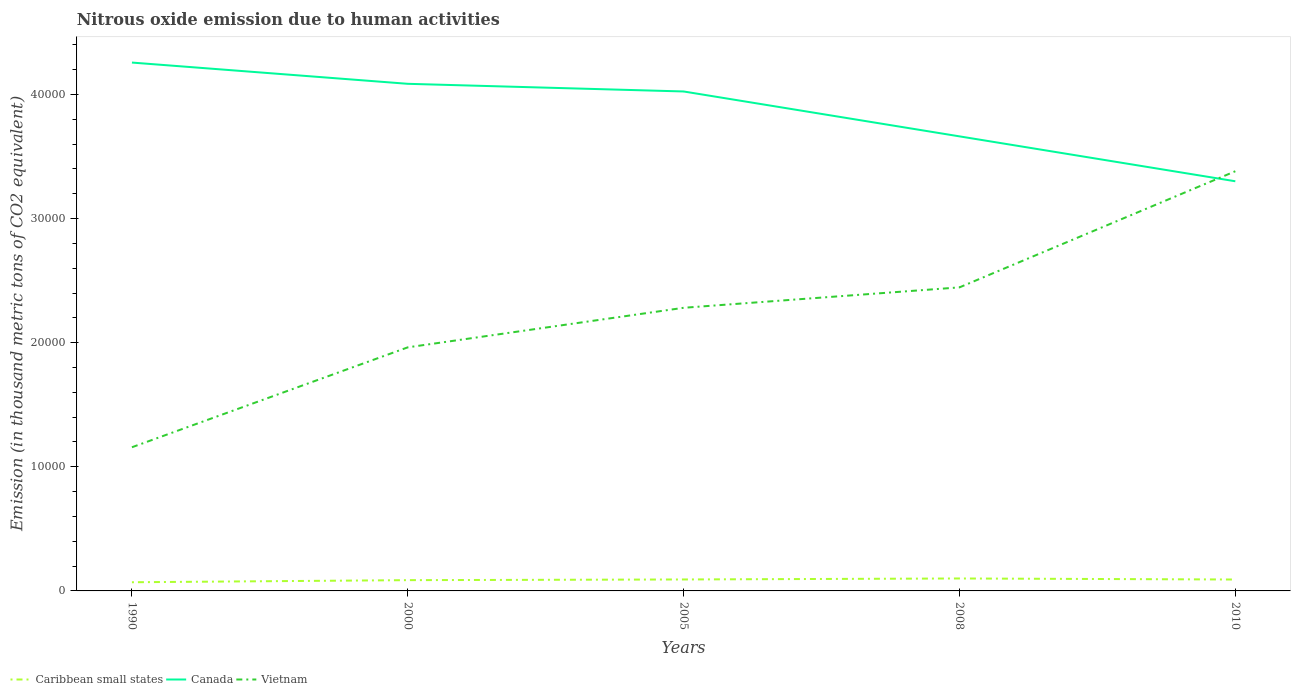Across all years, what is the maximum amount of nitrous oxide emitted in Caribbean small states?
Ensure brevity in your answer.  699.1. What is the total amount of nitrous oxide emitted in Caribbean small states in the graph?
Ensure brevity in your answer.  -135.7. What is the difference between the highest and the second highest amount of nitrous oxide emitted in Canada?
Make the answer very short. 9564.7. What is the difference between the highest and the lowest amount of nitrous oxide emitted in Vietnam?
Make the answer very short. 3. Is the amount of nitrous oxide emitted in Canada strictly greater than the amount of nitrous oxide emitted in Caribbean small states over the years?
Your answer should be compact. No. How many lines are there?
Provide a short and direct response. 3. How many years are there in the graph?
Make the answer very short. 5. What is the difference between two consecutive major ticks on the Y-axis?
Make the answer very short. 10000. How many legend labels are there?
Provide a succinct answer. 3. How are the legend labels stacked?
Give a very brief answer. Horizontal. What is the title of the graph?
Keep it short and to the point. Nitrous oxide emission due to human activities. Does "Malaysia" appear as one of the legend labels in the graph?
Provide a short and direct response. No. What is the label or title of the X-axis?
Your response must be concise. Years. What is the label or title of the Y-axis?
Your answer should be very brief. Emission (in thousand metric tons of CO2 equivalent). What is the Emission (in thousand metric tons of CO2 equivalent) in Caribbean small states in 1990?
Keep it short and to the point. 699.1. What is the Emission (in thousand metric tons of CO2 equivalent) of Canada in 1990?
Ensure brevity in your answer.  4.26e+04. What is the Emission (in thousand metric tons of CO2 equivalent) in Vietnam in 1990?
Make the answer very short. 1.16e+04. What is the Emission (in thousand metric tons of CO2 equivalent) of Caribbean small states in 2000?
Your response must be concise. 867.7. What is the Emission (in thousand metric tons of CO2 equivalent) of Canada in 2000?
Make the answer very short. 4.09e+04. What is the Emission (in thousand metric tons of CO2 equivalent) of Vietnam in 2000?
Provide a short and direct response. 1.96e+04. What is the Emission (in thousand metric tons of CO2 equivalent) of Caribbean small states in 2005?
Offer a terse response. 923.3. What is the Emission (in thousand metric tons of CO2 equivalent) in Canada in 2005?
Offer a terse response. 4.02e+04. What is the Emission (in thousand metric tons of CO2 equivalent) in Vietnam in 2005?
Offer a very short reply. 2.28e+04. What is the Emission (in thousand metric tons of CO2 equivalent) in Caribbean small states in 2008?
Ensure brevity in your answer.  1003.4. What is the Emission (in thousand metric tons of CO2 equivalent) in Canada in 2008?
Offer a very short reply. 3.66e+04. What is the Emission (in thousand metric tons of CO2 equivalent) in Vietnam in 2008?
Offer a terse response. 2.45e+04. What is the Emission (in thousand metric tons of CO2 equivalent) in Caribbean small states in 2010?
Your answer should be very brief. 919.1. What is the Emission (in thousand metric tons of CO2 equivalent) of Canada in 2010?
Offer a very short reply. 3.30e+04. What is the Emission (in thousand metric tons of CO2 equivalent) of Vietnam in 2010?
Offer a terse response. 3.38e+04. Across all years, what is the maximum Emission (in thousand metric tons of CO2 equivalent) in Caribbean small states?
Keep it short and to the point. 1003.4. Across all years, what is the maximum Emission (in thousand metric tons of CO2 equivalent) in Canada?
Provide a short and direct response. 4.26e+04. Across all years, what is the maximum Emission (in thousand metric tons of CO2 equivalent) of Vietnam?
Provide a short and direct response. 3.38e+04. Across all years, what is the minimum Emission (in thousand metric tons of CO2 equivalent) of Caribbean small states?
Provide a short and direct response. 699.1. Across all years, what is the minimum Emission (in thousand metric tons of CO2 equivalent) of Canada?
Keep it short and to the point. 3.30e+04. Across all years, what is the minimum Emission (in thousand metric tons of CO2 equivalent) of Vietnam?
Offer a very short reply. 1.16e+04. What is the total Emission (in thousand metric tons of CO2 equivalent) in Caribbean small states in the graph?
Provide a short and direct response. 4412.6. What is the total Emission (in thousand metric tons of CO2 equivalent) in Canada in the graph?
Your answer should be very brief. 1.93e+05. What is the total Emission (in thousand metric tons of CO2 equivalent) in Vietnam in the graph?
Offer a very short reply. 1.12e+05. What is the difference between the Emission (in thousand metric tons of CO2 equivalent) in Caribbean small states in 1990 and that in 2000?
Give a very brief answer. -168.6. What is the difference between the Emission (in thousand metric tons of CO2 equivalent) of Canada in 1990 and that in 2000?
Ensure brevity in your answer.  1712.6. What is the difference between the Emission (in thousand metric tons of CO2 equivalent) in Vietnam in 1990 and that in 2000?
Keep it short and to the point. -8050.5. What is the difference between the Emission (in thousand metric tons of CO2 equivalent) of Caribbean small states in 1990 and that in 2005?
Provide a succinct answer. -224.2. What is the difference between the Emission (in thousand metric tons of CO2 equivalent) of Canada in 1990 and that in 2005?
Offer a terse response. 2329.2. What is the difference between the Emission (in thousand metric tons of CO2 equivalent) of Vietnam in 1990 and that in 2005?
Give a very brief answer. -1.12e+04. What is the difference between the Emission (in thousand metric tons of CO2 equivalent) in Caribbean small states in 1990 and that in 2008?
Keep it short and to the point. -304.3. What is the difference between the Emission (in thousand metric tons of CO2 equivalent) in Canada in 1990 and that in 2008?
Your response must be concise. 5946.6. What is the difference between the Emission (in thousand metric tons of CO2 equivalent) of Vietnam in 1990 and that in 2008?
Your response must be concise. -1.29e+04. What is the difference between the Emission (in thousand metric tons of CO2 equivalent) of Caribbean small states in 1990 and that in 2010?
Provide a succinct answer. -220. What is the difference between the Emission (in thousand metric tons of CO2 equivalent) in Canada in 1990 and that in 2010?
Provide a succinct answer. 9564.7. What is the difference between the Emission (in thousand metric tons of CO2 equivalent) in Vietnam in 1990 and that in 2010?
Provide a short and direct response. -2.22e+04. What is the difference between the Emission (in thousand metric tons of CO2 equivalent) of Caribbean small states in 2000 and that in 2005?
Ensure brevity in your answer.  -55.6. What is the difference between the Emission (in thousand metric tons of CO2 equivalent) of Canada in 2000 and that in 2005?
Give a very brief answer. 616.6. What is the difference between the Emission (in thousand metric tons of CO2 equivalent) in Vietnam in 2000 and that in 2005?
Your answer should be very brief. -3186.8. What is the difference between the Emission (in thousand metric tons of CO2 equivalent) in Caribbean small states in 2000 and that in 2008?
Ensure brevity in your answer.  -135.7. What is the difference between the Emission (in thousand metric tons of CO2 equivalent) of Canada in 2000 and that in 2008?
Keep it short and to the point. 4234. What is the difference between the Emission (in thousand metric tons of CO2 equivalent) in Vietnam in 2000 and that in 2008?
Offer a terse response. -4832.2. What is the difference between the Emission (in thousand metric tons of CO2 equivalent) of Caribbean small states in 2000 and that in 2010?
Give a very brief answer. -51.4. What is the difference between the Emission (in thousand metric tons of CO2 equivalent) in Canada in 2000 and that in 2010?
Your answer should be compact. 7852.1. What is the difference between the Emission (in thousand metric tons of CO2 equivalent) in Vietnam in 2000 and that in 2010?
Ensure brevity in your answer.  -1.42e+04. What is the difference between the Emission (in thousand metric tons of CO2 equivalent) of Caribbean small states in 2005 and that in 2008?
Offer a terse response. -80.1. What is the difference between the Emission (in thousand metric tons of CO2 equivalent) in Canada in 2005 and that in 2008?
Offer a terse response. 3617.4. What is the difference between the Emission (in thousand metric tons of CO2 equivalent) in Vietnam in 2005 and that in 2008?
Your answer should be very brief. -1645.4. What is the difference between the Emission (in thousand metric tons of CO2 equivalent) in Caribbean small states in 2005 and that in 2010?
Offer a very short reply. 4.2. What is the difference between the Emission (in thousand metric tons of CO2 equivalent) in Canada in 2005 and that in 2010?
Offer a very short reply. 7235.5. What is the difference between the Emission (in thousand metric tons of CO2 equivalent) of Vietnam in 2005 and that in 2010?
Your answer should be very brief. -1.10e+04. What is the difference between the Emission (in thousand metric tons of CO2 equivalent) in Caribbean small states in 2008 and that in 2010?
Make the answer very short. 84.3. What is the difference between the Emission (in thousand metric tons of CO2 equivalent) in Canada in 2008 and that in 2010?
Ensure brevity in your answer.  3618.1. What is the difference between the Emission (in thousand metric tons of CO2 equivalent) in Vietnam in 2008 and that in 2010?
Keep it short and to the point. -9358.4. What is the difference between the Emission (in thousand metric tons of CO2 equivalent) of Caribbean small states in 1990 and the Emission (in thousand metric tons of CO2 equivalent) of Canada in 2000?
Make the answer very short. -4.02e+04. What is the difference between the Emission (in thousand metric tons of CO2 equivalent) in Caribbean small states in 1990 and the Emission (in thousand metric tons of CO2 equivalent) in Vietnam in 2000?
Ensure brevity in your answer.  -1.89e+04. What is the difference between the Emission (in thousand metric tons of CO2 equivalent) of Canada in 1990 and the Emission (in thousand metric tons of CO2 equivalent) of Vietnam in 2000?
Offer a terse response. 2.29e+04. What is the difference between the Emission (in thousand metric tons of CO2 equivalent) in Caribbean small states in 1990 and the Emission (in thousand metric tons of CO2 equivalent) in Canada in 2005?
Ensure brevity in your answer.  -3.95e+04. What is the difference between the Emission (in thousand metric tons of CO2 equivalent) of Caribbean small states in 1990 and the Emission (in thousand metric tons of CO2 equivalent) of Vietnam in 2005?
Keep it short and to the point. -2.21e+04. What is the difference between the Emission (in thousand metric tons of CO2 equivalent) in Canada in 1990 and the Emission (in thousand metric tons of CO2 equivalent) in Vietnam in 2005?
Your answer should be compact. 1.98e+04. What is the difference between the Emission (in thousand metric tons of CO2 equivalent) of Caribbean small states in 1990 and the Emission (in thousand metric tons of CO2 equivalent) of Canada in 2008?
Your response must be concise. -3.59e+04. What is the difference between the Emission (in thousand metric tons of CO2 equivalent) of Caribbean small states in 1990 and the Emission (in thousand metric tons of CO2 equivalent) of Vietnam in 2008?
Make the answer very short. -2.38e+04. What is the difference between the Emission (in thousand metric tons of CO2 equivalent) of Canada in 1990 and the Emission (in thousand metric tons of CO2 equivalent) of Vietnam in 2008?
Your response must be concise. 1.81e+04. What is the difference between the Emission (in thousand metric tons of CO2 equivalent) of Caribbean small states in 1990 and the Emission (in thousand metric tons of CO2 equivalent) of Canada in 2010?
Ensure brevity in your answer.  -3.23e+04. What is the difference between the Emission (in thousand metric tons of CO2 equivalent) of Caribbean small states in 1990 and the Emission (in thousand metric tons of CO2 equivalent) of Vietnam in 2010?
Your response must be concise. -3.31e+04. What is the difference between the Emission (in thousand metric tons of CO2 equivalent) of Canada in 1990 and the Emission (in thousand metric tons of CO2 equivalent) of Vietnam in 2010?
Offer a terse response. 8756.3. What is the difference between the Emission (in thousand metric tons of CO2 equivalent) in Caribbean small states in 2000 and the Emission (in thousand metric tons of CO2 equivalent) in Canada in 2005?
Provide a succinct answer. -3.94e+04. What is the difference between the Emission (in thousand metric tons of CO2 equivalent) in Caribbean small states in 2000 and the Emission (in thousand metric tons of CO2 equivalent) in Vietnam in 2005?
Your answer should be compact. -2.19e+04. What is the difference between the Emission (in thousand metric tons of CO2 equivalent) in Canada in 2000 and the Emission (in thousand metric tons of CO2 equivalent) in Vietnam in 2005?
Your response must be concise. 1.80e+04. What is the difference between the Emission (in thousand metric tons of CO2 equivalent) of Caribbean small states in 2000 and the Emission (in thousand metric tons of CO2 equivalent) of Canada in 2008?
Your response must be concise. -3.58e+04. What is the difference between the Emission (in thousand metric tons of CO2 equivalent) in Caribbean small states in 2000 and the Emission (in thousand metric tons of CO2 equivalent) in Vietnam in 2008?
Provide a succinct answer. -2.36e+04. What is the difference between the Emission (in thousand metric tons of CO2 equivalent) in Canada in 2000 and the Emission (in thousand metric tons of CO2 equivalent) in Vietnam in 2008?
Your answer should be compact. 1.64e+04. What is the difference between the Emission (in thousand metric tons of CO2 equivalent) in Caribbean small states in 2000 and the Emission (in thousand metric tons of CO2 equivalent) in Canada in 2010?
Your response must be concise. -3.21e+04. What is the difference between the Emission (in thousand metric tons of CO2 equivalent) in Caribbean small states in 2000 and the Emission (in thousand metric tons of CO2 equivalent) in Vietnam in 2010?
Keep it short and to the point. -3.30e+04. What is the difference between the Emission (in thousand metric tons of CO2 equivalent) in Canada in 2000 and the Emission (in thousand metric tons of CO2 equivalent) in Vietnam in 2010?
Offer a terse response. 7043.7. What is the difference between the Emission (in thousand metric tons of CO2 equivalent) of Caribbean small states in 2005 and the Emission (in thousand metric tons of CO2 equivalent) of Canada in 2008?
Ensure brevity in your answer.  -3.57e+04. What is the difference between the Emission (in thousand metric tons of CO2 equivalent) in Caribbean small states in 2005 and the Emission (in thousand metric tons of CO2 equivalent) in Vietnam in 2008?
Provide a short and direct response. -2.35e+04. What is the difference between the Emission (in thousand metric tons of CO2 equivalent) of Canada in 2005 and the Emission (in thousand metric tons of CO2 equivalent) of Vietnam in 2008?
Offer a terse response. 1.58e+04. What is the difference between the Emission (in thousand metric tons of CO2 equivalent) of Caribbean small states in 2005 and the Emission (in thousand metric tons of CO2 equivalent) of Canada in 2010?
Offer a very short reply. -3.21e+04. What is the difference between the Emission (in thousand metric tons of CO2 equivalent) of Caribbean small states in 2005 and the Emission (in thousand metric tons of CO2 equivalent) of Vietnam in 2010?
Offer a terse response. -3.29e+04. What is the difference between the Emission (in thousand metric tons of CO2 equivalent) in Canada in 2005 and the Emission (in thousand metric tons of CO2 equivalent) in Vietnam in 2010?
Keep it short and to the point. 6427.1. What is the difference between the Emission (in thousand metric tons of CO2 equivalent) in Caribbean small states in 2008 and the Emission (in thousand metric tons of CO2 equivalent) in Canada in 2010?
Provide a short and direct response. -3.20e+04. What is the difference between the Emission (in thousand metric tons of CO2 equivalent) of Caribbean small states in 2008 and the Emission (in thousand metric tons of CO2 equivalent) of Vietnam in 2010?
Keep it short and to the point. -3.28e+04. What is the difference between the Emission (in thousand metric tons of CO2 equivalent) in Canada in 2008 and the Emission (in thousand metric tons of CO2 equivalent) in Vietnam in 2010?
Provide a succinct answer. 2809.7. What is the average Emission (in thousand metric tons of CO2 equivalent) in Caribbean small states per year?
Make the answer very short. 882.52. What is the average Emission (in thousand metric tons of CO2 equivalent) of Canada per year?
Ensure brevity in your answer.  3.87e+04. What is the average Emission (in thousand metric tons of CO2 equivalent) in Vietnam per year?
Offer a very short reply. 2.25e+04. In the year 1990, what is the difference between the Emission (in thousand metric tons of CO2 equivalent) in Caribbean small states and Emission (in thousand metric tons of CO2 equivalent) in Canada?
Your response must be concise. -4.19e+04. In the year 1990, what is the difference between the Emission (in thousand metric tons of CO2 equivalent) in Caribbean small states and Emission (in thousand metric tons of CO2 equivalent) in Vietnam?
Your response must be concise. -1.09e+04. In the year 1990, what is the difference between the Emission (in thousand metric tons of CO2 equivalent) in Canada and Emission (in thousand metric tons of CO2 equivalent) in Vietnam?
Give a very brief answer. 3.10e+04. In the year 2000, what is the difference between the Emission (in thousand metric tons of CO2 equivalent) in Caribbean small states and Emission (in thousand metric tons of CO2 equivalent) in Canada?
Ensure brevity in your answer.  -4.00e+04. In the year 2000, what is the difference between the Emission (in thousand metric tons of CO2 equivalent) of Caribbean small states and Emission (in thousand metric tons of CO2 equivalent) of Vietnam?
Keep it short and to the point. -1.88e+04. In the year 2000, what is the difference between the Emission (in thousand metric tons of CO2 equivalent) in Canada and Emission (in thousand metric tons of CO2 equivalent) in Vietnam?
Your answer should be compact. 2.12e+04. In the year 2005, what is the difference between the Emission (in thousand metric tons of CO2 equivalent) of Caribbean small states and Emission (in thousand metric tons of CO2 equivalent) of Canada?
Offer a very short reply. -3.93e+04. In the year 2005, what is the difference between the Emission (in thousand metric tons of CO2 equivalent) of Caribbean small states and Emission (in thousand metric tons of CO2 equivalent) of Vietnam?
Make the answer very short. -2.19e+04. In the year 2005, what is the difference between the Emission (in thousand metric tons of CO2 equivalent) of Canada and Emission (in thousand metric tons of CO2 equivalent) of Vietnam?
Keep it short and to the point. 1.74e+04. In the year 2008, what is the difference between the Emission (in thousand metric tons of CO2 equivalent) in Caribbean small states and Emission (in thousand metric tons of CO2 equivalent) in Canada?
Ensure brevity in your answer.  -3.56e+04. In the year 2008, what is the difference between the Emission (in thousand metric tons of CO2 equivalent) of Caribbean small states and Emission (in thousand metric tons of CO2 equivalent) of Vietnam?
Your answer should be very brief. -2.35e+04. In the year 2008, what is the difference between the Emission (in thousand metric tons of CO2 equivalent) of Canada and Emission (in thousand metric tons of CO2 equivalent) of Vietnam?
Ensure brevity in your answer.  1.22e+04. In the year 2010, what is the difference between the Emission (in thousand metric tons of CO2 equivalent) of Caribbean small states and Emission (in thousand metric tons of CO2 equivalent) of Canada?
Ensure brevity in your answer.  -3.21e+04. In the year 2010, what is the difference between the Emission (in thousand metric tons of CO2 equivalent) in Caribbean small states and Emission (in thousand metric tons of CO2 equivalent) in Vietnam?
Your response must be concise. -3.29e+04. In the year 2010, what is the difference between the Emission (in thousand metric tons of CO2 equivalent) in Canada and Emission (in thousand metric tons of CO2 equivalent) in Vietnam?
Provide a succinct answer. -808.4. What is the ratio of the Emission (in thousand metric tons of CO2 equivalent) in Caribbean small states in 1990 to that in 2000?
Your answer should be compact. 0.81. What is the ratio of the Emission (in thousand metric tons of CO2 equivalent) in Canada in 1990 to that in 2000?
Your response must be concise. 1.04. What is the ratio of the Emission (in thousand metric tons of CO2 equivalent) of Vietnam in 1990 to that in 2000?
Your response must be concise. 0.59. What is the ratio of the Emission (in thousand metric tons of CO2 equivalent) in Caribbean small states in 1990 to that in 2005?
Your response must be concise. 0.76. What is the ratio of the Emission (in thousand metric tons of CO2 equivalent) of Canada in 1990 to that in 2005?
Offer a very short reply. 1.06. What is the ratio of the Emission (in thousand metric tons of CO2 equivalent) in Vietnam in 1990 to that in 2005?
Ensure brevity in your answer.  0.51. What is the ratio of the Emission (in thousand metric tons of CO2 equivalent) of Caribbean small states in 1990 to that in 2008?
Provide a short and direct response. 0.7. What is the ratio of the Emission (in thousand metric tons of CO2 equivalent) of Canada in 1990 to that in 2008?
Give a very brief answer. 1.16. What is the ratio of the Emission (in thousand metric tons of CO2 equivalent) of Vietnam in 1990 to that in 2008?
Your answer should be compact. 0.47. What is the ratio of the Emission (in thousand metric tons of CO2 equivalent) of Caribbean small states in 1990 to that in 2010?
Make the answer very short. 0.76. What is the ratio of the Emission (in thousand metric tons of CO2 equivalent) of Canada in 1990 to that in 2010?
Your response must be concise. 1.29. What is the ratio of the Emission (in thousand metric tons of CO2 equivalent) of Vietnam in 1990 to that in 2010?
Offer a very short reply. 0.34. What is the ratio of the Emission (in thousand metric tons of CO2 equivalent) in Caribbean small states in 2000 to that in 2005?
Offer a very short reply. 0.94. What is the ratio of the Emission (in thousand metric tons of CO2 equivalent) of Canada in 2000 to that in 2005?
Keep it short and to the point. 1.02. What is the ratio of the Emission (in thousand metric tons of CO2 equivalent) of Vietnam in 2000 to that in 2005?
Offer a very short reply. 0.86. What is the ratio of the Emission (in thousand metric tons of CO2 equivalent) of Caribbean small states in 2000 to that in 2008?
Make the answer very short. 0.86. What is the ratio of the Emission (in thousand metric tons of CO2 equivalent) of Canada in 2000 to that in 2008?
Provide a succinct answer. 1.12. What is the ratio of the Emission (in thousand metric tons of CO2 equivalent) in Vietnam in 2000 to that in 2008?
Give a very brief answer. 0.8. What is the ratio of the Emission (in thousand metric tons of CO2 equivalent) of Caribbean small states in 2000 to that in 2010?
Your answer should be very brief. 0.94. What is the ratio of the Emission (in thousand metric tons of CO2 equivalent) in Canada in 2000 to that in 2010?
Offer a very short reply. 1.24. What is the ratio of the Emission (in thousand metric tons of CO2 equivalent) in Vietnam in 2000 to that in 2010?
Provide a short and direct response. 0.58. What is the ratio of the Emission (in thousand metric tons of CO2 equivalent) in Caribbean small states in 2005 to that in 2008?
Provide a short and direct response. 0.92. What is the ratio of the Emission (in thousand metric tons of CO2 equivalent) in Canada in 2005 to that in 2008?
Ensure brevity in your answer.  1.1. What is the ratio of the Emission (in thousand metric tons of CO2 equivalent) in Vietnam in 2005 to that in 2008?
Offer a very short reply. 0.93. What is the ratio of the Emission (in thousand metric tons of CO2 equivalent) in Caribbean small states in 2005 to that in 2010?
Provide a succinct answer. 1. What is the ratio of the Emission (in thousand metric tons of CO2 equivalent) in Canada in 2005 to that in 2010?
Provide a succinct answer. 1.22. What is the ratio of the Emission (in thousand metric tons of CO2 equivalent) in Vietnam in 2005 to that in 2010?
Offer a very short reply. 0.67. What is the ratio of the Emission (in thousand metric tons of CO2 equivalent) of Caribbean small states in 2008 to that in 2010?
Keep it short and to the point. 1.09. What is the ratio of the Emission (in thousand metric tons of CO2 equivalent) of Canada in 2008 to that in 2010?
Your answer should be compact. 1.11. What is the ratio of the Emission (in thousand metric tons of CO2 equivalent) of Vietnam in 2008 to that in 2010?
Provide a succinct answer. 0.72. What is the difference between the highest and the second highest Emission (in thousand metric tons of CO2 equivalent) in Caribbean small states?
Provide a succinct answer. 80.1. What is the difference between the highest and the second highest Emission (in thousand metric tons of CO2 equivalent) in Canada?
Your response must be concise. 1712.6. What is the difference between the highest and the second highest Emission (in thousand metric tons of CO2 equivalent) in Vietnam?
Provide a succinct answer. 9358.4. What is the difference between the highest and the lowest Emission (in thousand metric tons of CO2 equivalent) of Caribbean small states?
Ensure brevity in your answer.  304.3. What is the difference between the highest and the lowest Emission (in thousand metric tons of CO2 equivalent) of Canada?
Give a very brief answer. 9564.7. What is the difference between the highest and the lowest Emission (in thousand metric tons of CO2 equivalent) of Vietnam?
Offer a terse response. 2.22e+04. 